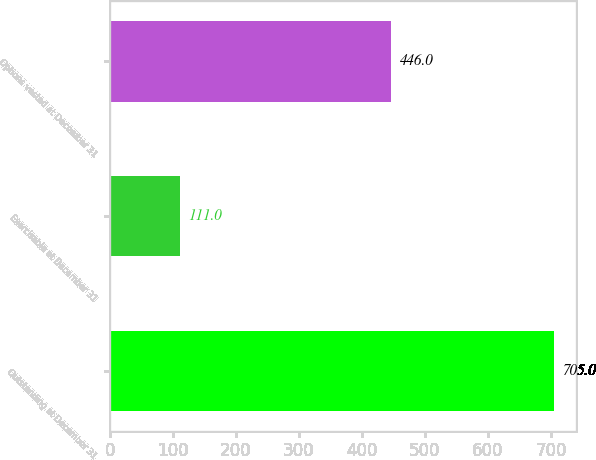Convert chart. <chart><loc_0><loc_0><loc_500><loc_500><bar_chart><fcel>Outstanding at December 31<fcel>Exercisable at December 31<fcel>Options vested at December 31<nl><fcel>705<fcel>111<fcel>446<nl></chart> 